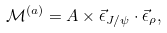Convert formula to latex. <formula><loc_0><loc_0><loc_500><loc_500>\mathcal { M } ^ { ( a ) } = A \times \vec { \epsilon } _ { J / \psi } \cdot \vec { \epsilon } _ { \rho } ,</formula> 